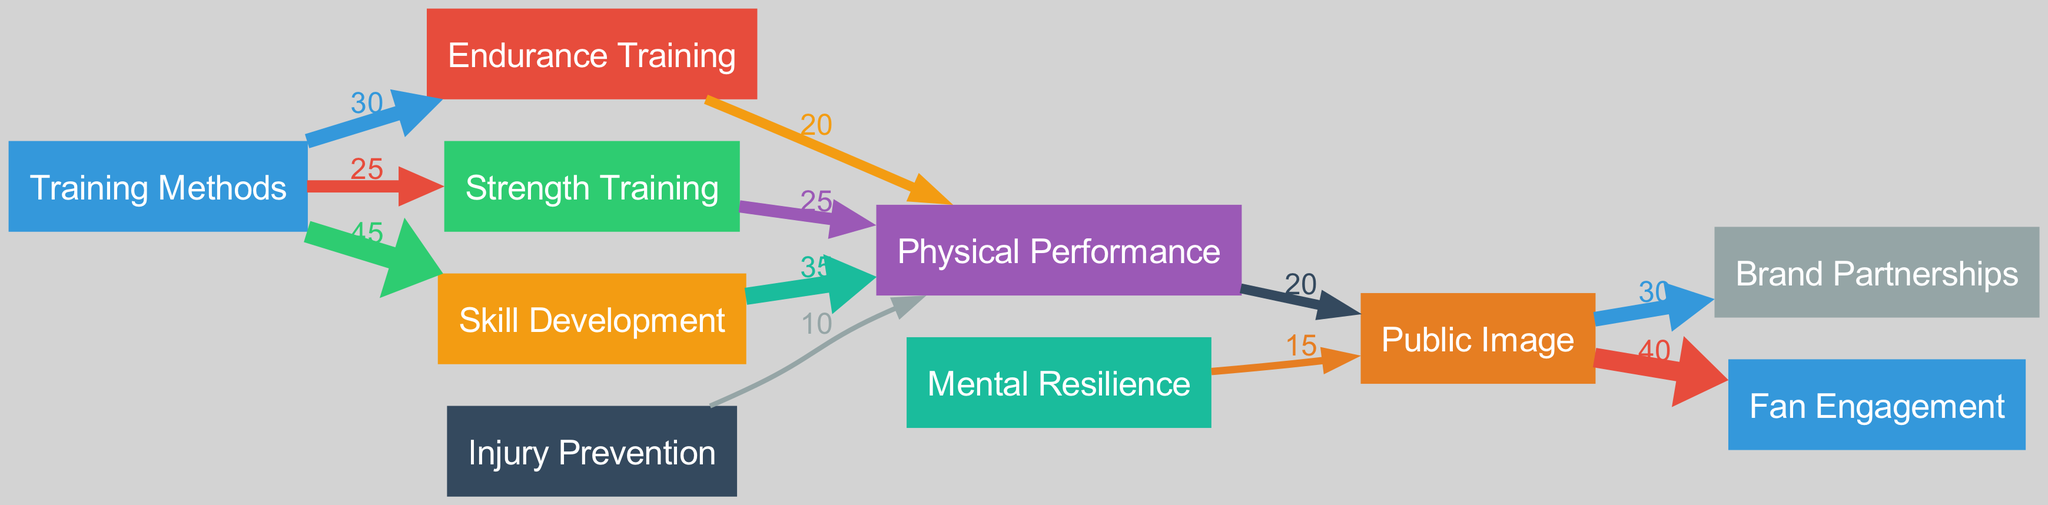What is the value for Skill Development? The edge from the "Training Methods" node to the "Skill Development" node indicates a value of 45. This is directly observed in the diagram, specifically from the link information.
Answer: 45 How many nodes are present in the diagram? The diagram includes ten nodes: Training Methods, Endurance Training, Strength Training, Skill Development, Physical Performance, Mental Resilience, Injury Prevention, Public Image, Brand Partnerships, and Fan Engagement. Counting these gives a total of 10.
Answer: 10 Which training method has the lowest influence on Physical Performance? The influences shown indicate that Endurance Training affects Physical Performance with a value of 20, Strength Training has 25, Skill Development has 35, and Injury Prevention has 10. Since Injury Prevention has the lowest value of 10 going to Physical Performance, it's the answer.
Answer: Injury Prevention What percentage of Physical Performance influences Public Image? The flow from Physical Performance to Public Image shows a value of 20. To compute the percentage, divide the value of this influence by the total of 20 plus 15 (from Mental Resilience), which totals 35. Thus, the percentage is (20/35) * 100 ≈ 57.1%.
Answer: Approximately fifty-seven percent Which method contributes more towards Public Image: Physical Performance or Mental Resilience? Physical Performance contributes 20 towards Public Image, while Mental Resilience contributes 15. Comparing these values directly, Physical Performance contributes more.
Answer: Physical Performance How many edges are there connecting to the Public Image node? The edges flowing into the Public Image node are from Physical Performance (20) and Mental Resilience (15), totaling two edges.
Answer: Two edges What is the total influence from Skill Development to Physical Performance? Skill Development has a direct influence of 35 to Physical Performance, as represented by that edge in the diagram.
Answer: 35 How does Endurance Training influence Public Image indirectly? Endurance Training flows to Physical Performance, which subsequently influences Public Image with a value of 20. This establishes an indirect influence from Endurance Training to Public Image through Physical Performance.
Answer: Through Physical Performance Which node has the highest total outgoing influence? The Public Image node has outgoing influences of 30 to Brand Partnerships and 40 to Fan Engagement, totaling 70, which is the highest among all nodes when comparing values.
Answer: Public Image 